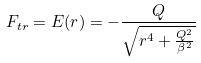Convert formula to latex. <formula><loc_0><loc_0><loc_500><loc_500>F _ { t r } = E ( r ) = - \frac { Q } { \sqrt { r ^ { 4 } + \frac { Q ^ { 2 } } { \beta ^ { 2 } } } }</formula> 